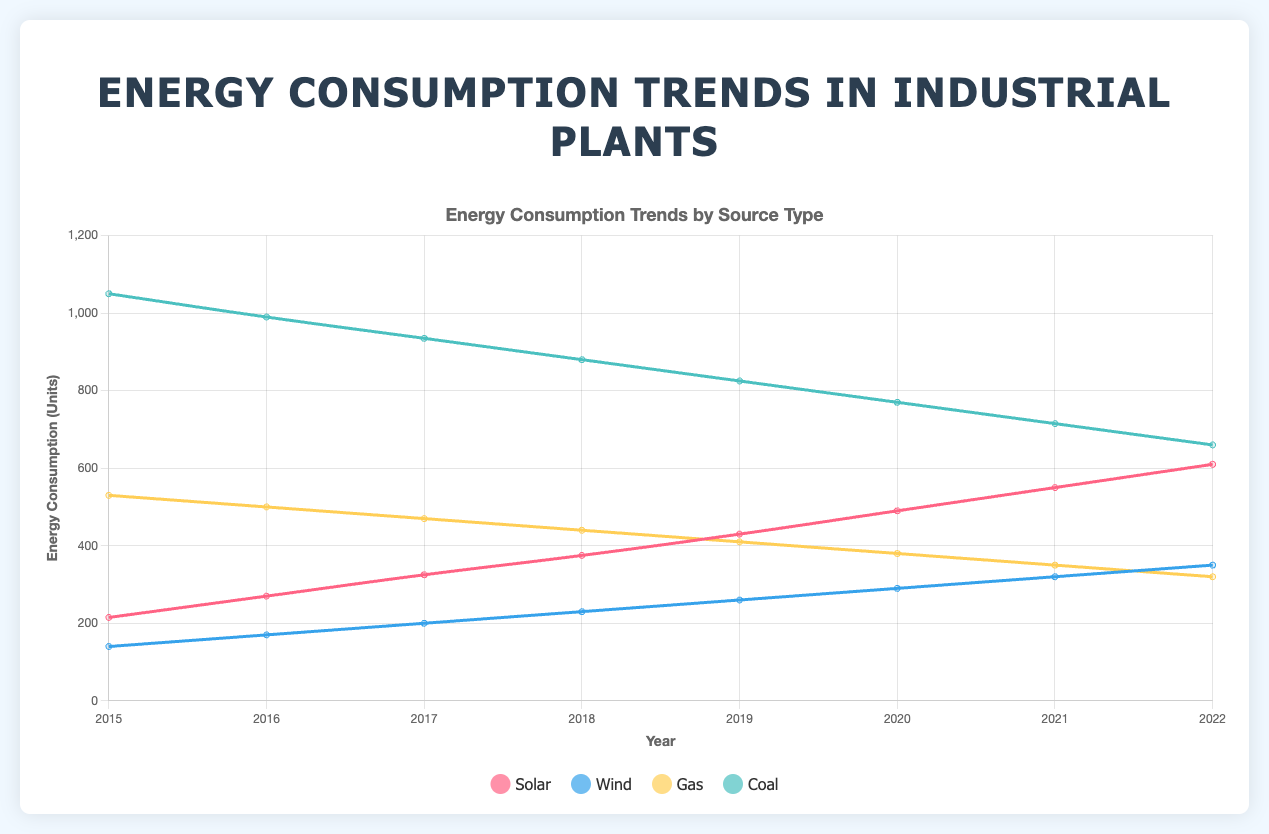What is the overall trend of solar energy consumption from 2015 to 2022? To identify the trend, look at the line representing solar energy on the plot. The overall trend is upward, as the values for solar energy consumption by the plants increase from 2015 to 2022.
Answer: Upward Which energy source showed the most significant decrease in consumption from 2015 to 2022? To find this, compare the starting and ending values of each energy source. Coal consumption decreases from 2015 to 2022, as indicated by the declining slope of its line.
Answer: Coal Which year did Alpha Manufacturing consume the least gas? Look at the trend of gas consumption for Alpha Manufacturing over the years and find the smallest value. 2022 has the lowest gas consumption, at 80 units.
Answer: 2022 Which type of energy had the most consistent consumption over the observed years? Consistency is indicated by the least fluctuation in the line representing the source. The wind energy plot shows the least fluctuation from year to year.
Answer: Wind In which year was Beta Chemicals' energy consumption from coal the highest? By looking at the coal consumption trend for Beta Chemicals, the highest point reached is in 2015, with 400 units.
Answer: 2015 How does the overall trend for wind energy compare to solar energy consumption? Compare both lines; while both trends generally increase, solar has a steeper upward trend compared to the relatively modest increase in wind energy consumption.
Answer: Solar increases faster Which plant increased its solar energy consumption the most from 2015 to 2022? By comparing the initial and final values of each plant's solar energy consumption, Gamma Electronics shows the most significant increase.
Answer: Gamma Electronics Is there a correlation between the decrease in coal consumption and the increase in solar consumption? To explore this, observe the inverse relationship over time. As coal consumption decreases, solar consumption increases, suggesting an attempt to replace coal with solar energy.
Answer: Yes What is the sum of the solar energy consumed by all plants in 2022? Sum the values from the solar energy category for 2022: 220 + 160 + 230 = 610 units.
Answer: 610 Did Gamma Electronics consume more energy from gas or wind in 2020? Compare the values for gas and wind for Gamma Electronics in 2020. It consumed 130 units of gas versus 100 units of wind.
Answer: Gas 